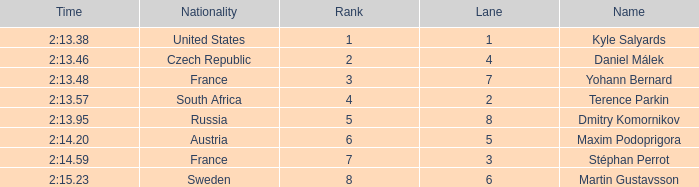What was Stéphan Perrot rank average? 7.0. 